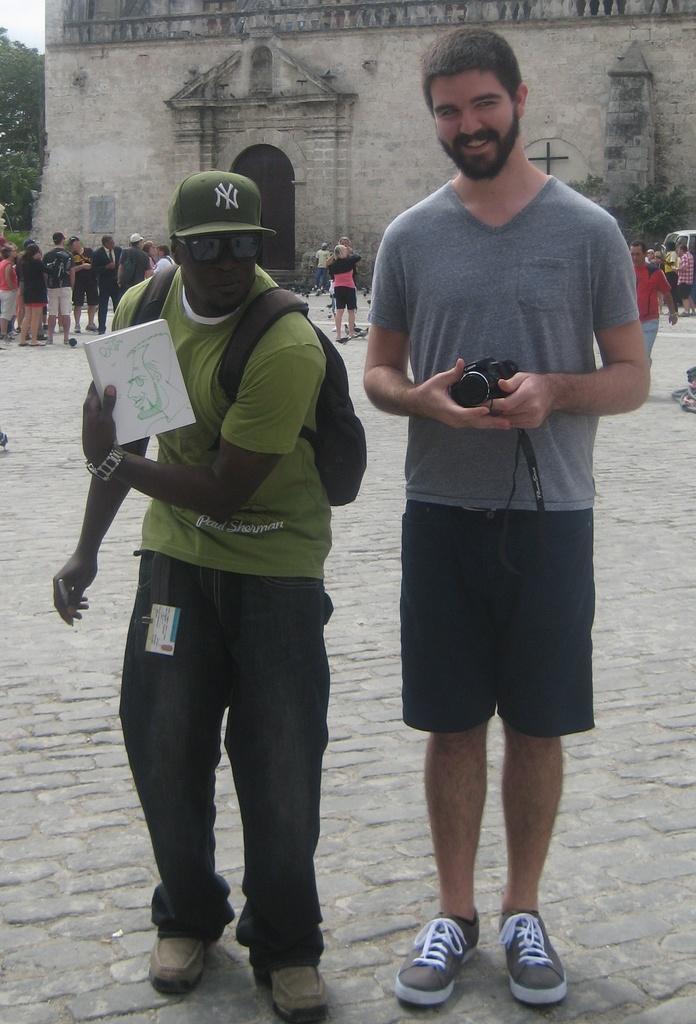Could you give a brief overview of what you see in this image? In this image there are two persons standing , a person holding a camera, another person holding a book, and in the background there are group of people standing, building, tree,sky. 